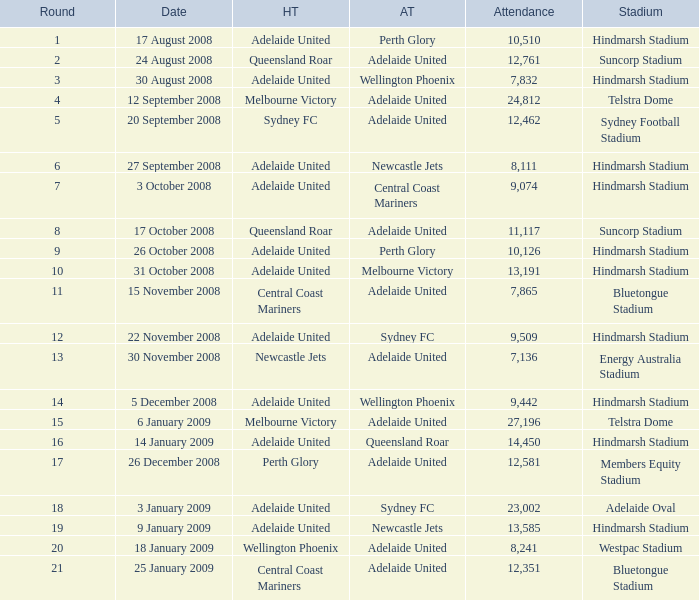What is the least round for the game played at Members Equity Stadium in from of 12,581 people? None. 